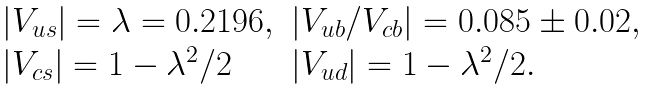<formula> <loc_0><loc_0><loc_500><loc_500>\begin{array} { l l } | V _ { u s } | = \lambda = 0 . 2 1 9 6 , & | V _ { u b } / V _ { c b } | = 0 . 0 8 5 \pm 0 . 0 2 , \\ | V _ { c s } | = 1 - \lambda ^ { 2 } / 2 & | V _ { u d } | = 1 - \lambda ^ { 2 } / 2 . \end{array}</formula> 